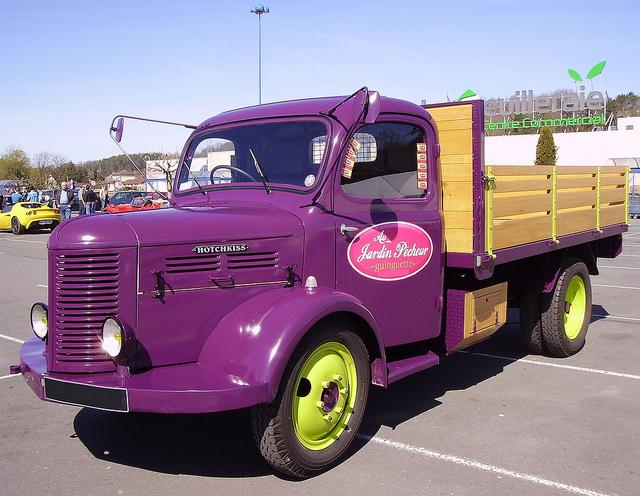Which television character is the same color as this truck?

Choices:
A) uncle fester
B) barney
C) lamb chop
D) popeye barney 